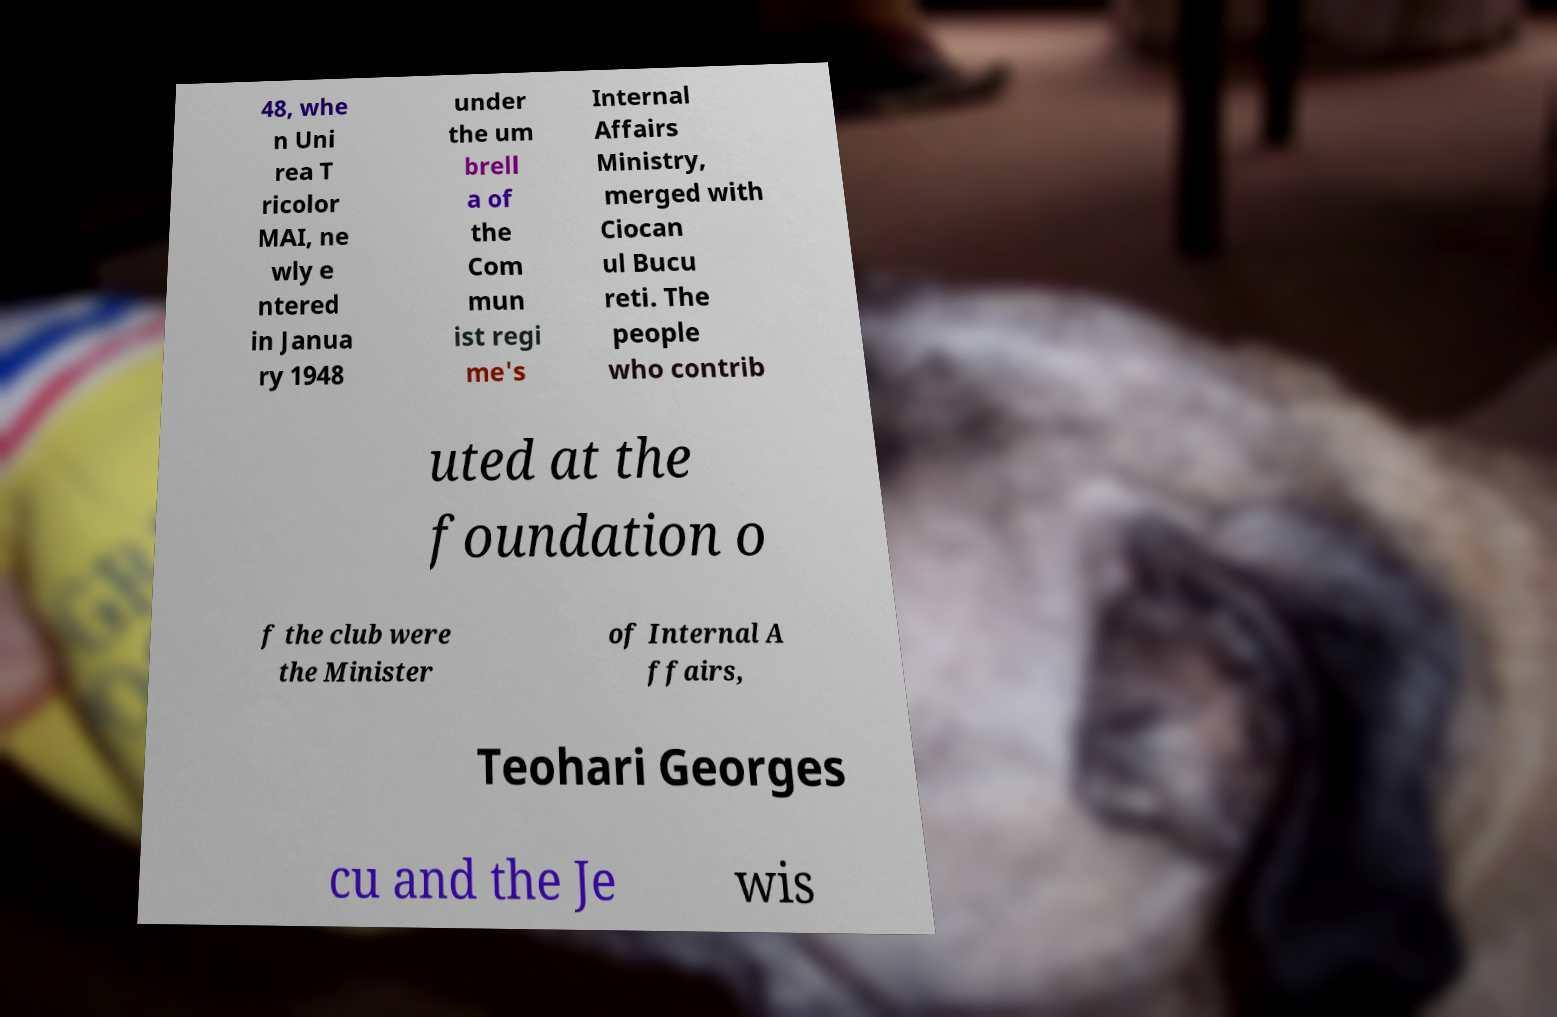Please identify and transcribe the text found in this image. 48, whe n Uni rea T ricolor MAI, ne wly e ntered in Janua ry 1948 under the um brell a of the Com mun ist regi me's Internal Affairs Ministry, merged with Ciocan ul Bucu reti. The people who contrib uted at the foundation o f the club were the Minister of Internal A ffairs, Teohari Georges cu and the Je wis 